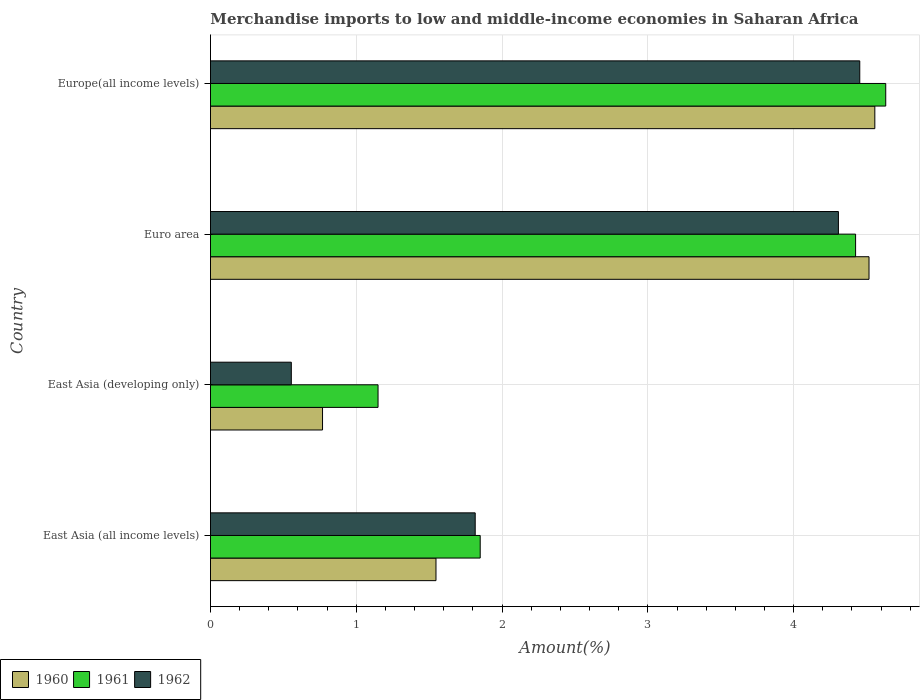How many different coloured bars are there?
Offer a terse response. 3. Are the number of bars per tick equal to the number of legend labels?
Your answer should be very brief. Yes. Are the number of bars on each tick of the Y-axis equal?
Make the answer very short. Yes. How many bars are there on the 4th tick from the bottom?
Give a very brief answer. 3. What is the label of the 4th group of bars from the top?
Your answer should be compact. East Asia (all income levels). In how many cases, is the number of bars for a given country not equal to the number of legend labels?
Offer a terse response. 0. What is the percentage of amount earned from merchandise imports in 1961 in Euro area?
Keep it short and to the point. 4.43. Across all countries, what is the maximum percentage of amount earned from merchandise imports in 1961?
Give a very brief answer. 4.63. Across all countries, what is the minimum percentage of amount earned from merchandise imports in 1960?
Give a very brief answer. 0.77. In which country was the percentage of amount earned from merchandise imports in 1961 maximum?
Make the answer very short. Europe(all income levels). In which country was the percentage of amount earned from merchandise imports in 1961 minimum?
Offer a terse response. East Asia (developing only). What is the total percentage of amount earned from merchandise imports in 1962 in the graph?
Your answer should be very brief. 11.13. What is the difference between the percentage of amount earned from merchandise imports in 1960 in East Asia (developing only) and that in Euro area?
Offer a very short reply. -3.75. What is the difference between the percentage of amount earned from merchandise imports in 1962 in East Asia (all income levels) and the percentage of amount earned from merchandise imports in 1960 in East Asia (developing only)?
Offer a terse response. 1.05. What is the average percentage of amount earned from merchandise imports in 1960 per country?
Offer a terse response. 2.85. What is the difference between the percentage of amount earned from merchandise imports in 1961 and percentage of amount earned from merchandise imports in 1962 in East Asia (all income levels)?
Keep it short and to the point. 0.03. What is the ratio of the percentage of amount earned from merchandise imports in 1962 in East Asia (developing only) to that in Europe(all income levels)?
Your response must be concise. 0.12. Is the percentage of amount earned from merchandise imports in 1960 in East Asia (all income levels) less than that in Euro area?
Offer a terse response. Yes. What is the difference between the highest and the second highest percentage of amount earned from merchandise imports in 1961?
Your response must be concise. 0.21. What is the difference between the highest and the lowest percentage of amount earned from merchandise imports in 1961?
Offer a terse response. 3.48. What does the 2nd bar from the bottom in Euro area represents?
Give a very brief answer. 1961. Is it the case that in every country, the sum of the percentage of amount earned from merchandise imports in 1961 and percentage of amount earned from merchandise imports in 1962 is greater than the percentage of amount earned from merchandise imports in 1960?
Offer a terse response. Yes. How many bars are there?
Ensure brevity in your answer.  12. Are all the bars in the graph horizontal?
Offer a terse response. Yes. How many legend labels are there?
Your answer should be very brief. 3. How are the legend labels stacked?
Give a very brief answer. Horizontal. What is the title of the graph?
Offer a terse response. Merchandise imports to low and middle-income economies in Saharan Africa. What is the label or title of the X-axis?
Make the answer very short. Amount(%). What is the label or title of the Y-axis?
Your answer should be very brief. Country. What is the Amount(%) in 1960 in East Asia (all income levels)?
Provide a short and direct response. 1.55. What is the Amount(%) of 1961 in East Asia (all income levels)?
Your response must be concise. 1.85. What is the Amount(%) of 1962 in East Asia (all income levels)?
Provide a succinct answer. 1.82. What is the Amount(%) in 1960 in East Asia (developing only)?
Your answer should be very brief. 0.77. What is the Amount(%) of 1961 in East Asia (developing only)?
Offer a very short reply. 1.15. What is the Amount(%) of 1962 in East Asia (developing only)?
Offer a terse response. 0.55. What is the Amount(%) of 1960 in Euro area?
Offer a very short reply. 4.52. What is the Amount(%) in 1961 in Euro area?
Offer a terse response. 4.43. What is the Amount(%) in 1962 in Euro area?
Provide a short and direct response. 4.31. What is the Amount(%) in 1960 in Europe(all income levels)?
Your answer should be compact. 4.56. What is the Amount(%) in 1961 in Europe(all income levels)?
Your answer should be compact. 4.63. What is the Amount(%) of 1962 in Europe(all income levels)?
Keep it short and to the point. 4.45. Across all countries, what is the maximum Amount(%) in 1960?
Provide a short and direct response. 4.56. Across all countries, what is the maximum Amount(%) of 1961?
Your response must be concise. 4.63. Across all countries, what is the maximum Amount(%) of 1962?
Ensure brevity in your answer.  4.45. Across all countries, what is the minimum Amount(%) of 1960?
Your response must be concise. 0.77. Across all countries, what is the minimum Amount(%) of 1961?
Make the answer very short. 1.15. Across all countries, what is the minimum Amount(%) in 1962?
Give a very brief answer. 0.55. What is the total Amount(%) in 1960 in the graph?
Make the answer very short. 11.39. What is the total Amount(%) of 1961 in the graph?
Make the answer very short. 12.06. What is the total Amount(%) of 1962 in the graph?
Keep it short and to the point. 11.13. What is the difference between the Amount(%) of 1960 in East Asia (all income levels) and that in East Asia (developing only)?
Provide a short and direct response. 0.78. What is the difference between the Amount(%) of 1961 in East Asia (all income levels) and that in East Asia (developing only)?
Provide a succinct answer. 0.7. What is the difference between the Amount(%) in 1962 in East Asia (all income levels) and that in East Asia (developing only)?
Offer a very short reply. 1.26. What is the difference between the Amount(%) in 1960 in East Asia (all income levels) and that in Euro area?
Your response must be concise. -2.97. What is the difference between the Amount(%) of 1961 in East Asia (all income levels) and that in Euro area?
Your answer should be compact. -2.58. What is the difference between the Amount(%) of 1962 in East Asia (all income levels) and that in Euro area?
Your response must be concise. -2.49. What is the difference between the Amount(%) of 1960 in East Asia (all income levels) and that in Europe(all income levels)?
Ensure brevity in your answer.  -3.01. What is the difference between the Amount(%) of 1961 in East Asia (all income levels) and that in Europe(all income levels)?
Provide a succinct answer. -2.78. What is the difference between the Amount(%) of 1962 in East Asia (all income levels) and that in Europe(all income levels)?
Give a very brief answer. -2.64. What is the difference between the Amount(%) in 1960 in East Asia (developing only) and that in Euro area?
Your answer should be very brief. -3.75. What is the difference between the Amount(%) of 1961 in East Asia (developing only) and that in Euro area?
Your response must be concise. -3.28. What is the difference between the Amount(%) of 1962 in East Asia (developing only) and that in Euro area?
Give a very brief answer. -3.75. What is the difference between the Amount(%) in 1960 in East Asia (developing only) and that in Europe(all income levels)?
Provide a succinct answer. -3.79. What is the difference between the Amount(%) in 1961 in East Asia (developing only) and that in Europe(all income levels)?
Your response must be concise. -3.48. What is the difference between the Amount(%) of 1962 in East Asia (developing only) and that in Europe(all income levels)?
Give a very brief answer. -3.9. What is the difference between the Amount(%) in 1960 in Euro area and that in Europe(all income levels)?
Provide a short and direct response. -0.04. What is the difference between the Amount(%) in 1961 in Euro area and that in Europe(all income levels)?
Ensure brevity in your answer.  -0.21. What is the difference between the Amount(%) of 1962 in Euro area and that in Europe(all income levels)?
Ensure brevity in your answer.  -0.15. What is the difference between the Amount(%) in 1960 in East Asia (all income levels) and the Amount(%) in 1961 in East Asia (developing only)?
Ensure brevity in your answer.  0.4. What is the difference between the Amount(%) in 1961 in East Asia (all income levels) and the Amount(%) in 1962 in East Asia (developing only)?
Ensure brevity in your answer.  1.3. What is the difference between the Amount(%) of 1960 in East Asia (all income levels) and the Amount(%) of 1961 in Euro area?
Your response must be concise. -2.88. What is the difference between the Amount(%) of 1960 in East Asia (all income levels) and the Amount(%) of 1962 in Euro area?
Make the answer very short. -2.76. What is the difference between the Amount(%) of 1961 in East Asia (all income levels) and the Amount(%) of 1962 in Euro area?
Ensure brevity in your answer.  -2.46. What is the difference between the Amount(%) in 1960 in East Asia (all income levels) and the Amount(%) in 1961 in Europe(all income levels)?
Your answer should be compact. -3.08. What is the difference between the Amount(%) of 1960 in East Asia (all income levels) and the Amount(%) of 1962 in Europe(all income levels)?
Make the answer very short. -2.91. What is the difference between the Amount(%) of 1961 in East Asia (all income levels) and the Amount(%) of 1962 in Europe(all income levels)?
Make the answer very short. -2.6. What is the difference between the Amount(%) in 1960 in East Asia (developing only) and the Amount(%) in 1961 in Euro area?
Make the answer very short. -3.66. What is the difference between the Amount(%) in 1960 in East Asia (developing only) and the Amount(%) in 1962 in Euro area?
Give a very brief answer. -3.54. What is the difference between the Amount(%) of 1961 in East Asia (developing only) and the Amount(%) of 1962 in Euro area?
Give a very brief answer. -3.16. What is the difference between the Amount(%) in 1960 in East Asia (developing only) and the Amount(%) in 1961 in Europe(all income levels)?
Your response must be concise. -3.86. What is the difference between the Amount(%) of 1960 in East Asia (developing only) and the Amount(%) of 1962 in Europe(all income levels)?
Your answer should be compact. -3.68. What is the difference between the Amount(%) of 1961 in East Asia (developing only) and the Amount(%) of 1962 in Europe(all income levels)?
Keep it short and to the point. -3.3. What is the difference between the Amount(%) in 1960 in Euro area and the Amount(%) in 1961 in Europe(all income levels)?
Ensure brevity in your answer.  -0.11. What is the difference between the Amount(%) in 1960 in Euro area and the Amount(%) in 1962 in Europe(all income levels)?
Make the answer very short. 0.06. What is the difference between the Amount(%) in 1961 in Euro area and the Amount(%) in 1962 in Europe(all income levels)?
Give a very brief answer. -0.03. What is the average Amount(%) in 1960 per country?
Your response must be concise. 2.85. What is the average Amount(%) of 1961 per country?
Offer a terse response. 3.01. What is the average Amount(%) of 1962 per country?
Keep it short and to the point. 2.78. What is the difference between the Amount(%) of 1960 and Amount(%) of 1961 in East Asia (all income levels)?
Offer a terse response. -0.3. What is the difference between the Amount(%) in 1960 and Amount(%) in 1962 in East Asia (all income levels)?
Provide a succinct answer. -0.27. What is the difference between the Amount(%) in 1961 and Amount(%) in 1962 in East Asia (all income levels)?
Offer a terse response. 0.03. What is the difference between the Amount(%) of 1960 and Amount(%) of 1961 in East Asia (developing only)?
Your answer should be very brief. -0.38. What is the difference between the Amount(%) of 1960 and Amount(%) of 1962 in East Asia (developing only)?
Ensure brevity in your answer.  0.21. What is the difference between the Amount(%) in 1961 and Amount(%) in 1962 in East Asia (developing only)?
Ensure brevity in your answer.  0.59. What is the difference between the Amount(%) of 1960 and Amount(%) of 1961 in Euro area?
Provide a short and direct response. 0.09. What is the difference between the Amount(%) of 1960 and Amount(%) of 1962 in Euro area?
Your answer should be very brief. 0.21. What is the difference between the Amount(%) of 1961 and Amount(%) of 1962 in Euro area?
Offer a very short reply. 0.12. What is the difference between the Amount(%) in 1960 and Amount(%) in 1961 in Europe(all income levels)?
Your answer should be very brief. -0.07. What is the difference between the Amount(%) in 1960 and Amount(%) in 1962 in Europe(all income levels)?
Provide a short and direct response. 0.1. What is the difference between the Amount(%) of 1961 and Amount(%) of 1962 in Europe(all income levels)?
Your answer should be very brief. 0.18. What is the ratio of the Amount(%) in 1960 in East Asia (all income levels) to that in East Asia (developing only)?
Give a very brief answer. 2.01. What is the ratio of the Amount(%) of 1961 in East Asia (all income levels) to that in East Asia (developing only)?
Your answer should be very brief. 1.61. What is the ratio of the Amount(%) in 1962 in East Asia (all income levels) to that in East Asia (developing only)?
Keep it short and to the point. 3.27. What is the ratio of the Amount(%) in 1960 in East Asia (all income levels) to that in Euro area?
Provide a short and direct response. 0.34. What is the ratio of the Amount(%) in 1961 in East Asia (all income levels) to that in Euro area?
Keep it short and to the point. 0.42. What is the ratio of the Amount(%) in 1962 in East Asia (all income levels) to that in Euro area?
Your response must be concise. 0.42. What is the ratio of the Amount(%) in 1960 in East Asia (all income levels) to that in Europe(all income levels)?
Offer a terse response. 0.34. What is the ratio of the Amount(%) of 1961 in East Asia (all income levels) to that in Europe(all income levels)?
Make the answer very short. 0.4. What is the ratio of the Amount(%) of 1962 in East Asia (all income levels) to that in Europe(all income levels)?
Keep it short and to the point. 0.41. What is the ratio of the Amount(%) of 1960 in East Asia (developing only) to that in Euro area?
Ensure brevity in your answer.  0.17. What is the ratio of the Amount(%) of 1961 in East Asia (developing only) to that in Euro area?
Provide a short and direct response. 0.26. What is the ratio of the Amount(%) of 1962 in East Asia (developing only) to that in Euro area?
Provide a succinct answer. 0.13. What is the ratio of the Amount(%) in 1960 in East Asia (developing only) to that in Europe(all income levels)?
Offer a terse response. 0.17. What is the ratio of the Amount(%) of 1961 in East Asia (developing only) to that in Europe(all income levels)?
Your answer should be very brief. 0.25. What is the ratio of the Amount(%) in 1962 in East Asia (developing only) to that in Europe(all income levels)?
Provide a succinct answer. 0.12. What is the ratio of the Amount(%) in 1960 in Euro area to that in Europe(all income levels)?
Offer a terse response. 0.99. What is the ratio of the Amount(%) in 1961 in Euro area to that in Europe(all income levels)?
Make the answer very short. 0.96. What is the ratio of the Amount(%) in 1962 in Euro area to that in Europe(all income levels)?
Your response must be concise. 0.97. What is the difference between the highest and the second highest Amount(%) of 1960?
Keep it short and to the point. 0.04. What is the difference between the highest and the second highest Amount(%) in 1961?
Your response must be concise. 0.21. What is the difference between the highest and the second highest Amount(%) in 1962?
Your answer should be compact. 0.15. What is the difference between the highest and the lowest Amount(%) of 1960?
Your answer should be compact. 3.79. What is the difference between the highest and the lowest Amount(%) of 1961?
Keep it short and to the point. 3.48. What is the difference between the highest and the lowest Amount(%) in 1962?
Make the answer very short. 3.9. 